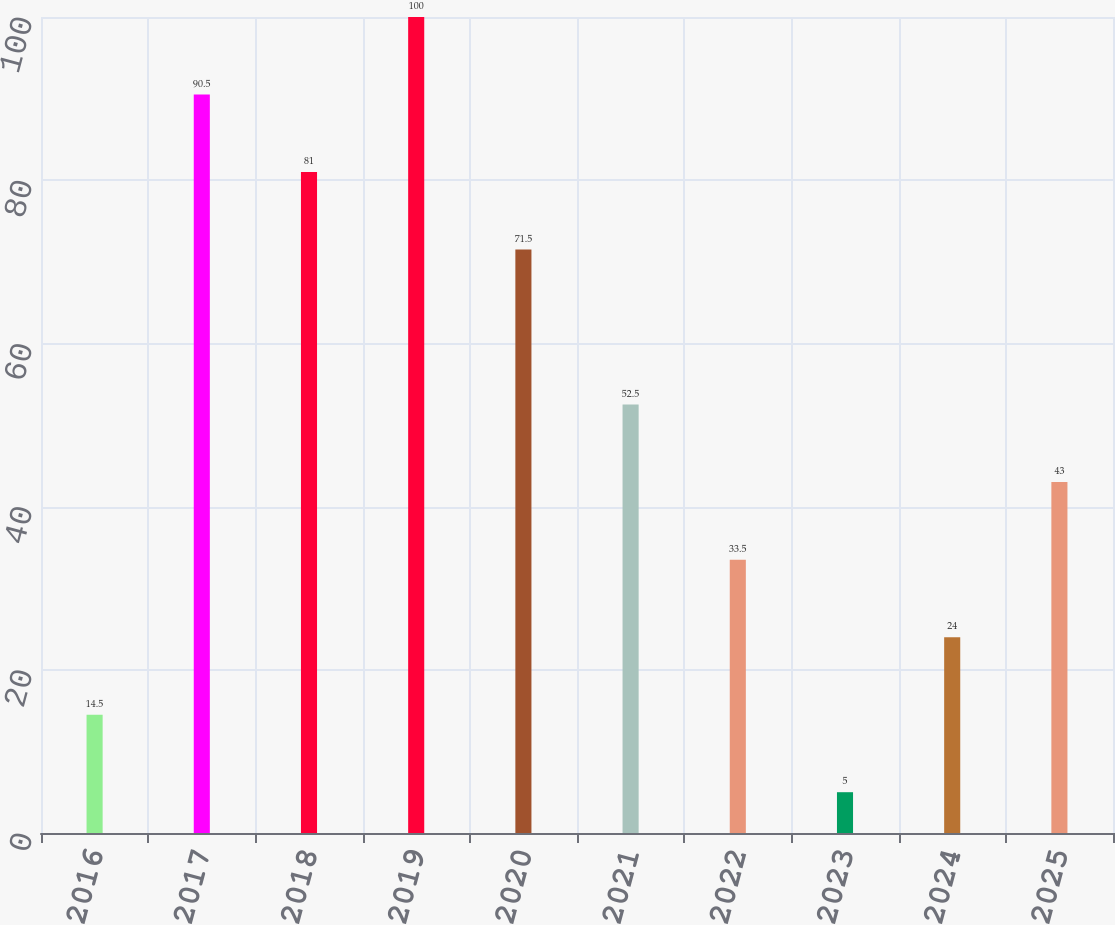Convert chart. <chart><loc_0><loc_0><loc_500><loc_500><bar_chart><fcel>2016<fcel>2017<fcel>2018<fcel>2019<fcel>2020<fcel>2021<fcel>2022<fcel>2023<fcel>2024<fcel>2025<nl><fcel>14.5<fcel>90.5<fcel>81<fcel>100<fcel>71.5<fcel>52.5<fcel>33.5<fcel>5<fcel>24<fcel>43<nl></chart> 